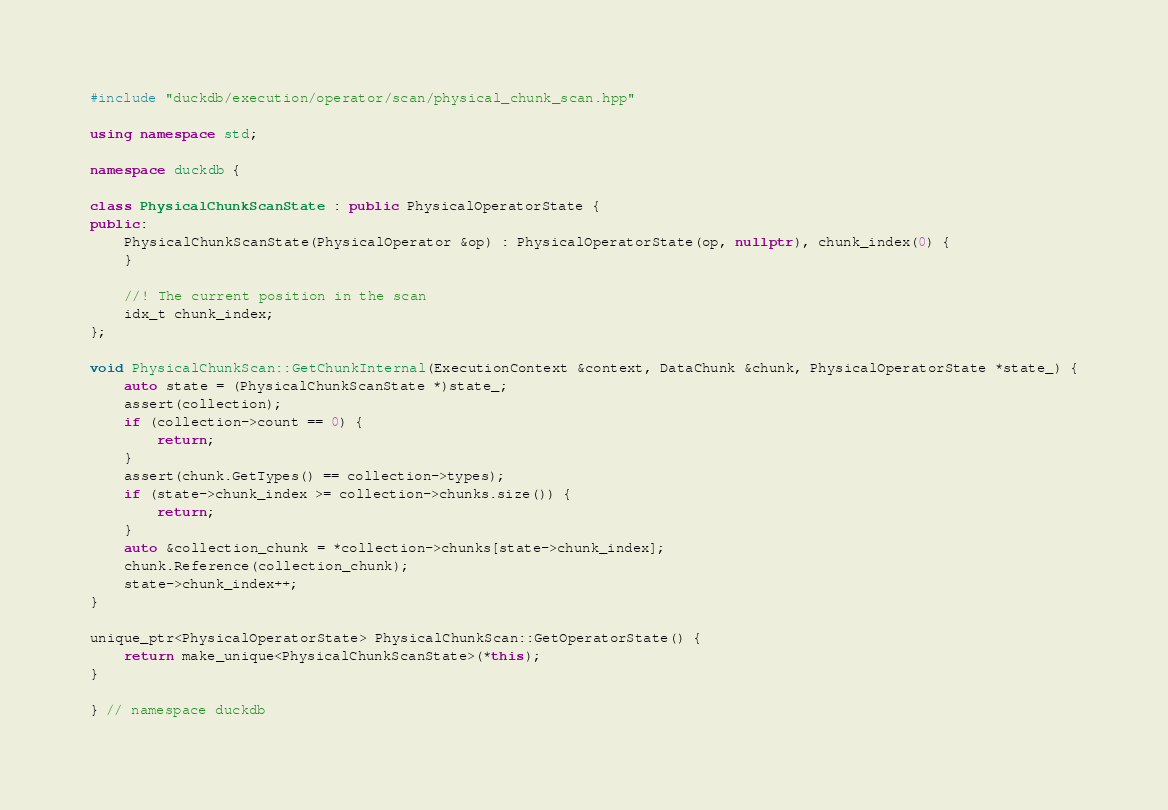Convert code to text. <code><loc_0><loc_0><loc_500><loc_500><_C++_>#include "duckdb/execution/operator/scan/physical_chunk_scan.hpp"

using namespace std;

namespace duckdb {

class PhysicalChunkScanState : public PhysicalOperatorState {
public:
	PhysicalChunkScanState(PhysicalOperator &op) : PhysicalOperatorState(op, nullptr), chunk_index(0) {
	}

	//! The current position in the scan
	idx_t chunk_index;
};

void PhysicalChunkScan::GetChunkInternal(ExecutionContext &context, DataChunk &chunk, PhysicalOperatorState *state_) {
	auto state = (PhysicalChunkScanState *)state_;
	assert(collection);
	if (collection->count == 0) {
		return;
	}
	assert(chunk.GetTypes() == collection->types);
	if (state->chunk_index >= collection->chunks.size()) {
		return;
	}
	auto &collection_chunk = *collection->chunks[state->chunk_index];
	chunk.Reference(collection_chunk);
	state->chunk_index++;
}

unique_ptr<PhysicalOperatorState> PhysicalChunkScan::GetOperatorState() {
	return make_unique<PhysicalChunkScanState>(*this);
}

} // namespace duckdb
</code> 